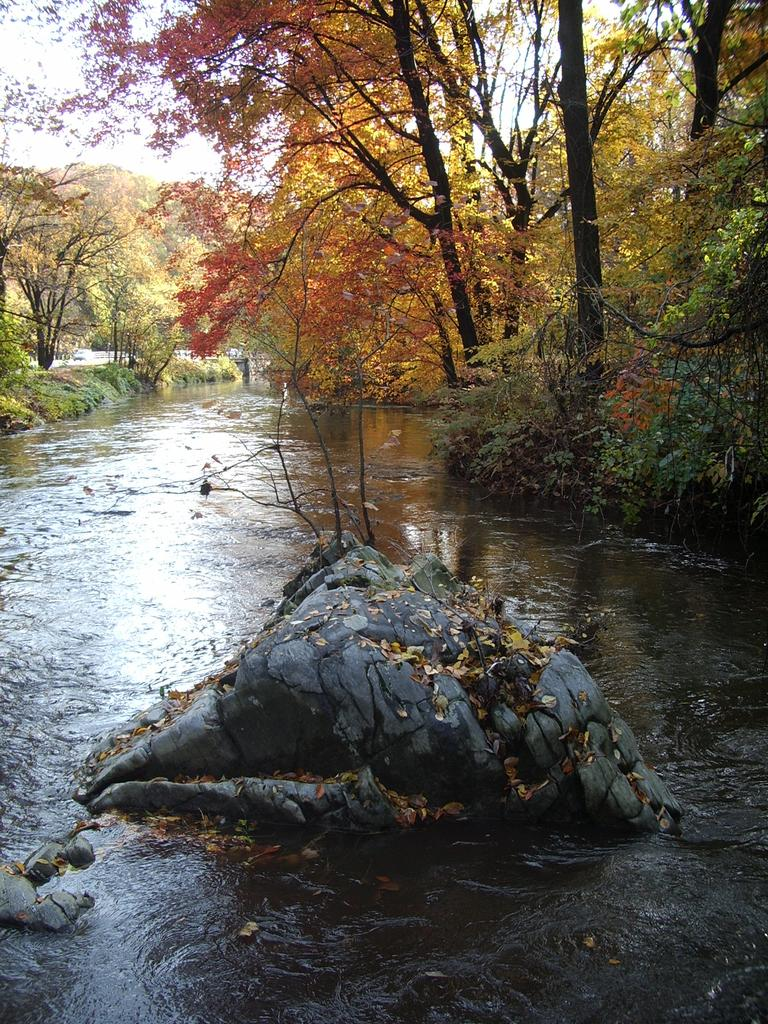What is the primary element visible in the image? There is water in the image. What other objects or features can be seen in the image? There are rocks and trees in the image. What type of wool is being used to create the key in the image? There is no wool or key present in the image. Who is the manager in the image? There is no manager or any indication of a person in charge in the image. 